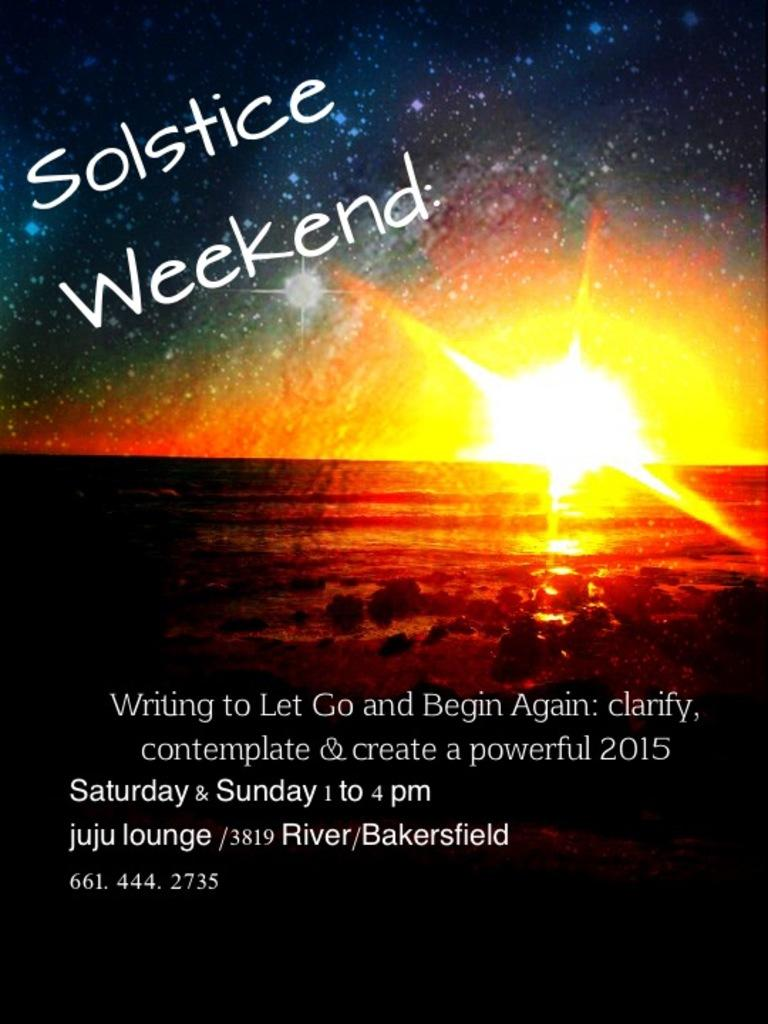<image>
Provide a brief description of the given image. According to the poster Solstice Weekend begins on Saturday 